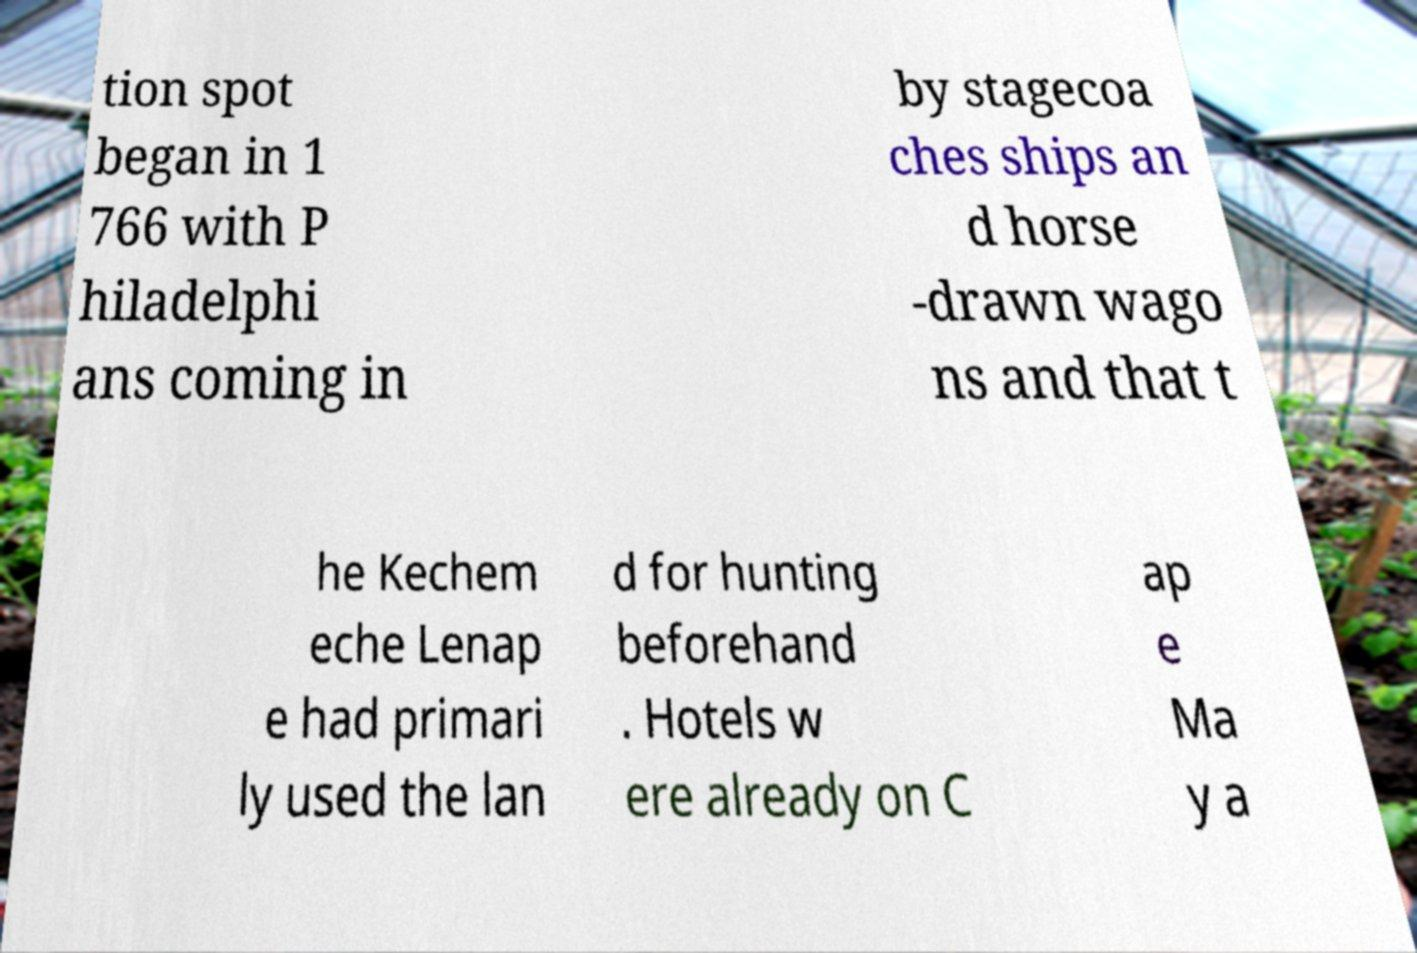There's text embedded in this image that I need extracted. Can you transcribe it verbatim? tion spot began in 1 766 with P hiladelphi ans coming in by stagecoa ches ships an d horse -drawn wago ns and that t he Kechem eche Lenap e had primari ly used the lan d for hunting beforehand . Hotels w ere already on C ap e Ma y a 